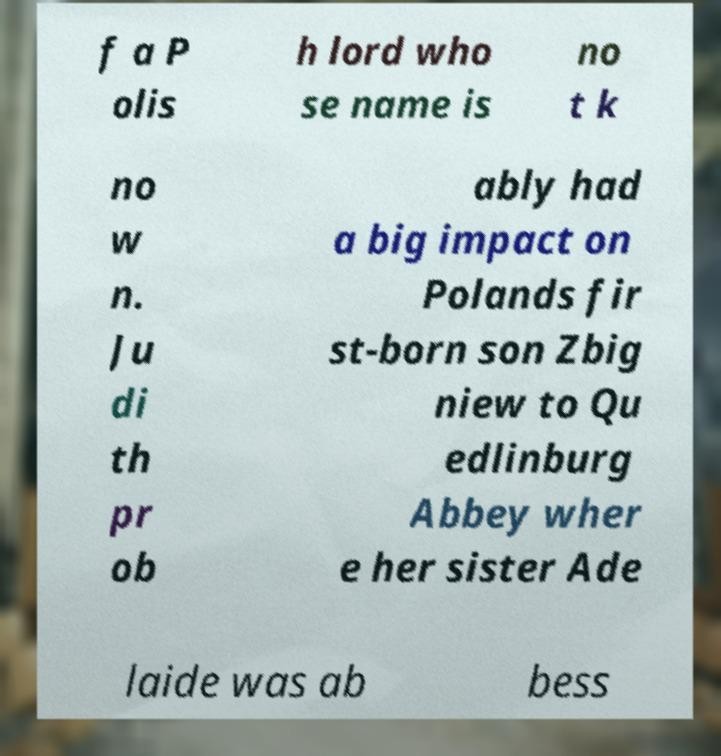Can you read and provide the text displayed in the image?This photo seems to have some interesting text. Can you extract and type it out for me? f a P olis h lord who se name is no t k no w n. Ju di th pr ob ably had a big impact on Polands fir st-born son Zbig niew to Qu edlinburg Abbey wher e her sister Ade laide was ab bess 